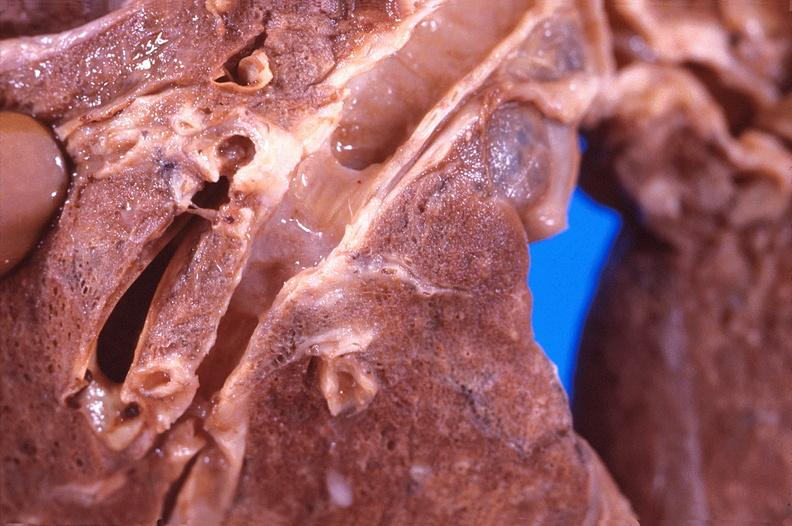does this image show lung, bronchiiogenic carcinoma?
Answer the question using a single word or phrase. Yes 